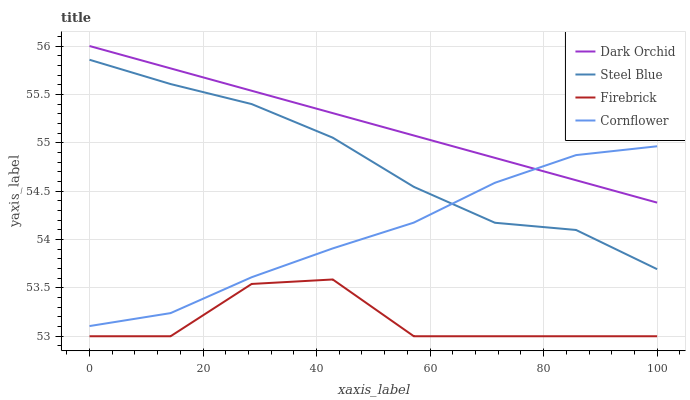Does Firebrick have the minimum area under the curve?
Answer yes or no. Yes. Does Dark Orchid have the maximum area under the curve?
Answer yes or no. Yes. Does Steel Blue have the minimum area under the curve?
Answer yes or no. No. Does Steel Blue have the maximum area under the curve?
Answer yes or no. No. Is Dark Orchid the smoothest?
Answer yes or no. Yes. Is Firebrick the roughest?
Answer yes or no. Yes. Is Steel Blue the smoothest?
Answer yes or no. No. Is Steel Blue the roughest?
Answer yes or no. No. Does Firebrick have the lowest value?
Answer yes or no. Yes. Does Steel Blue have the lowest value?
Answer yes or no. No. Does Dark Orchid have the highest value?
Answer yes or no. Yes. Does Steel Blue have the highest value?
Answer yes or no. No. Is Firebrick less than Steel Blue?
Answer yes or no. Yes. Is Cornflower greater than Firebrick?
Answer yes or no. Yes. Does Cornflower intersect Steel Blue?
Answer yes or no. Yes. Is Cornflower less than Steel Blue?
Answer yes or no. No. Is Cornflower greater than Steel Blue?
Answer yes or no. No. Does Firebrick intersect Steel Blue?
Answer yes or no. No. 